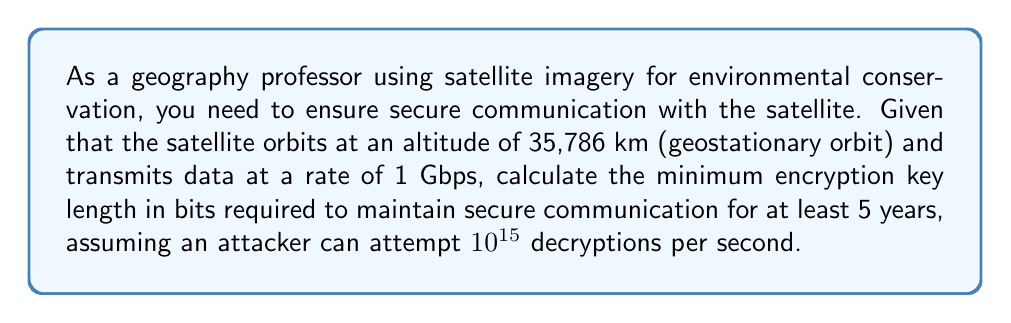What is the answer to this math problem? To determine the required encryption key length, we'll follow these steps:

1. Calculate the total number of bits transmitted in 5 years:
   $$ \text{Total bits} = 1 \text{ Gbps} \times 5 \text{ years} \times 365 \text{ days/year} \times 24 \text{ hours/day} \times 3600 \text{ seconds/hour} $$
   $$ = 1 \times 10^9 \times 5 \times 365 \times 24 \times 3600 = 1.577 \times 10^{17} \text{ bits} $$

2. Determine the number of decryption attempts an attacker can make in 5 years:
   $$ \text{Decryption attempts} = 10^{15} \text{ attempts/second} \times 5 \text{ years} \times 365 \text{ days/year} \times 24 \text{ hours/day} \times 3600 \text{ seconds/hour} $$
   $$ = 10^{15} \times 5 \times 365 \times 24 \times 3600 = 1.577 \times 10^{23} \text{ attempts} $$

3. The encryption key space must be larger than both the total bits transmitted and the number of decryption attempts. We'll use the larger of the two:
   $$ \text{Key space} > 1.577 \times 10^{23} $$

4. Calculate the minimum key length in bits:
   $$ 2^n > 1.577 \times 10^{23} $$
   $$ n > \log_2(1.577 \times 10^{23}) $$
   $$ n > 77.79 $$

5. Round up to the nearest whole number:
   $$ n = 78 \text{ bits} $$

However, in practice, we use standardized key lengths. The next standard key length above 78 bits is 128 bits, which provides a significant safety margin.
Answer: 128 bits 